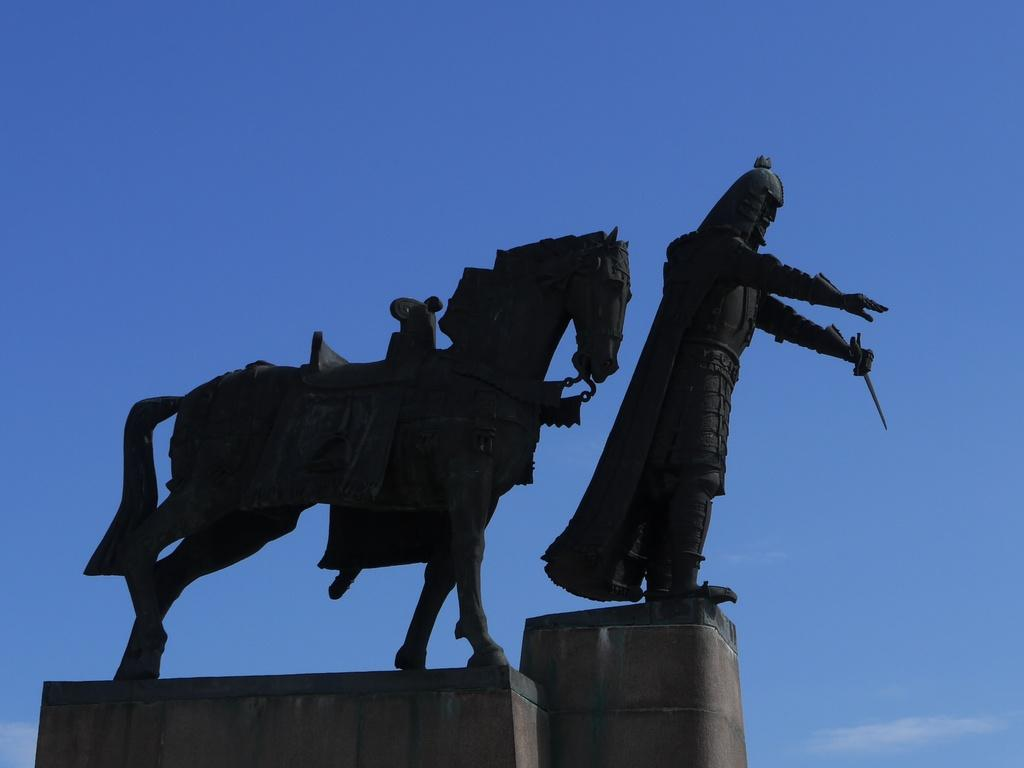What can be seen in the image besides the sky? There are statues in the image. What is the condition of the sky in the image? The sky appears to be cloudy in the image. What type of animal is wearing a veil in the image? There is no animal wearing a veil present in the image. How much profit can be made from the statues in the image? The image does not provide any information about the profitability of the statues. 